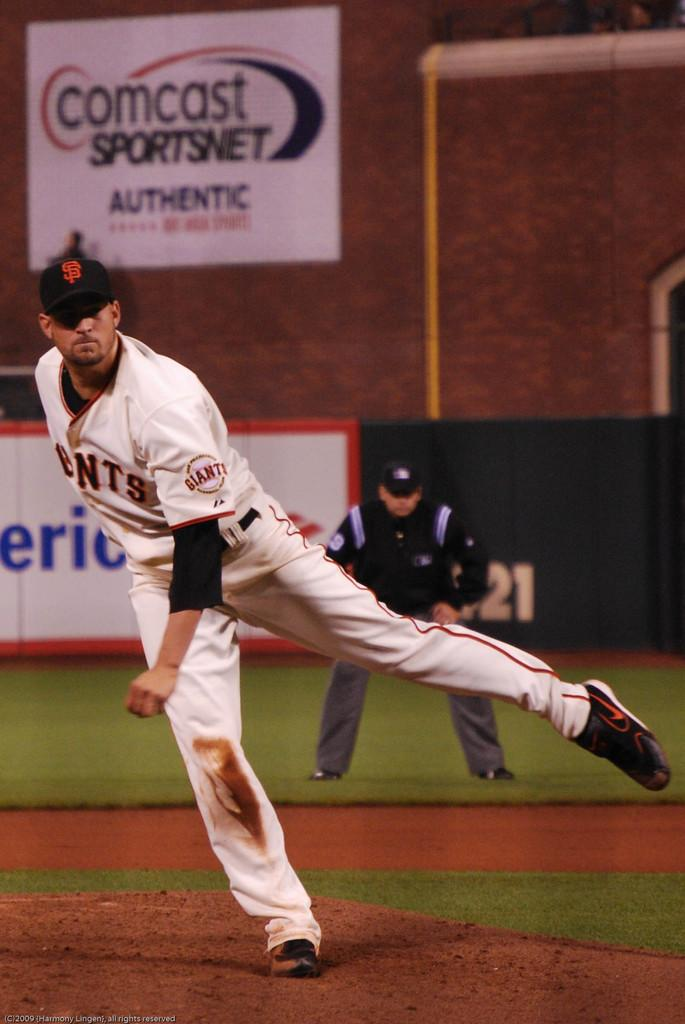<image>
Offer a succinct explanation of the picture presented. A baseball player playing near a  large Comcast poster. 